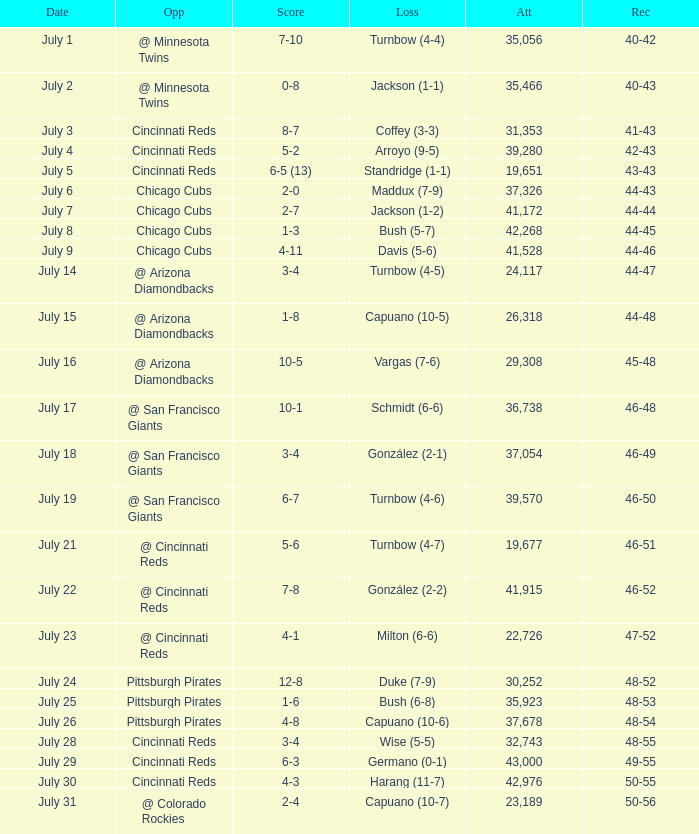What was the loss of the Brewers game when the record was 46-48? Schmidt (6-6). 